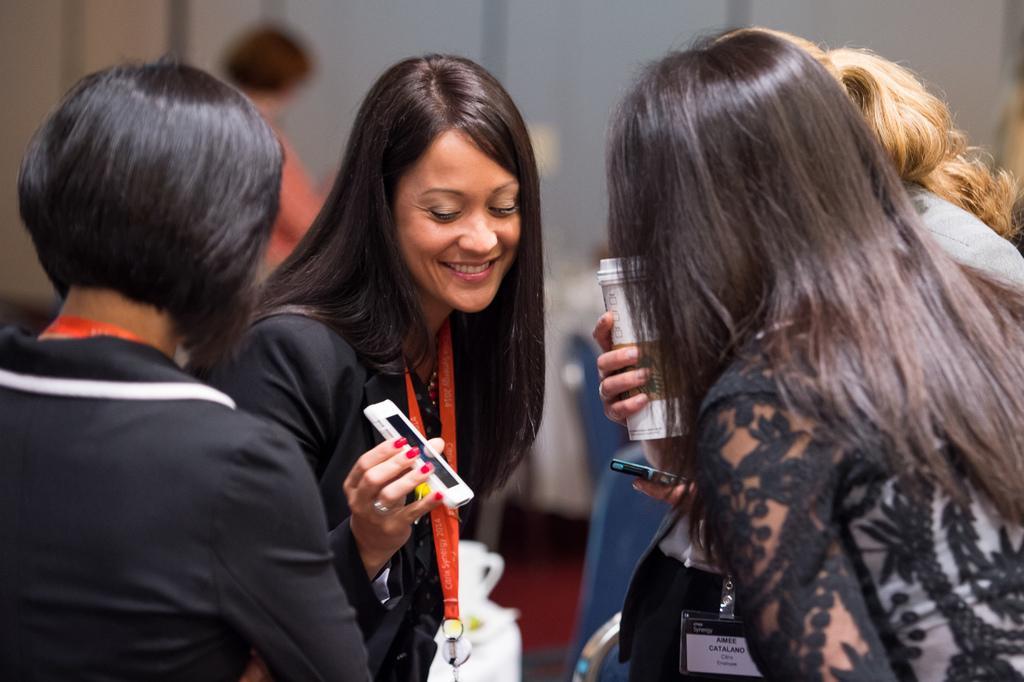Could you give a brief overview of what you see in this image? In this picture there are group of people. There is a woman smiling and holding the device. At the back there are chairs and there might be a table and there is a wall. At the bottom there might be a mat on the floor. 